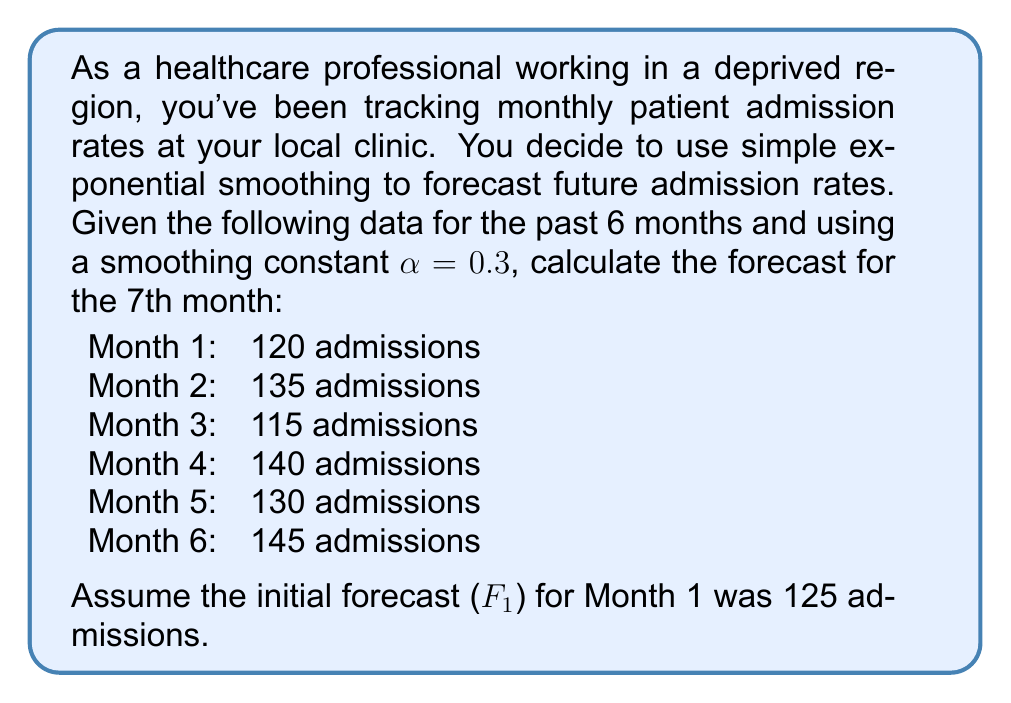Teach me how to tackle this problem. To solve this problem, we'll use the simple exponential smoothing formula:

$$F_{t+1} = \alpha Y_t + (1-\alpha)F_t$$

Where:
$F_{t+1}$ is the forecast for the next period
$\alpha$ is the smoothing constant (0.3 in this case)
$Y_t$ is the actual value for the current period
$F_t$ is the forecast for the current period

Let's calculate the forecasts for each month:

1. Month 1:
   $F_1 = 125$ (given)

2. Month 2:
   $F_2 = 0.3(120) + 0.7(125) = 36 + 87.5 = 123.5$

3. Month 3:
   $F_3 = 0.3(135) + 0.7(123.5) = 40.5 + 86.45 = 126.95$

4. Month 4:
   $F_4 = 0.3(115) + 0.7(126.95) = 34.5 + 88.865 = 123.365$

5. Month 5:
   $F_5 = 0.3(140) + 0.7(123.365) = 42 + 86.3555 = 128.3555$

6. Month 6:
   $F_6 = 0.3(130) + 0.7(128.3555) = 39 + 89.84885 = 128.84885$

7. Month 7 (forecast):
   $F_7 = 0.3(145) + 0.7(128.84885) = 43.5 + 90.194195 = 133.694195$

Therefore, the forecast for the 7th month is approximately 133.69 admissions.
Answer: 133.69 admissions 